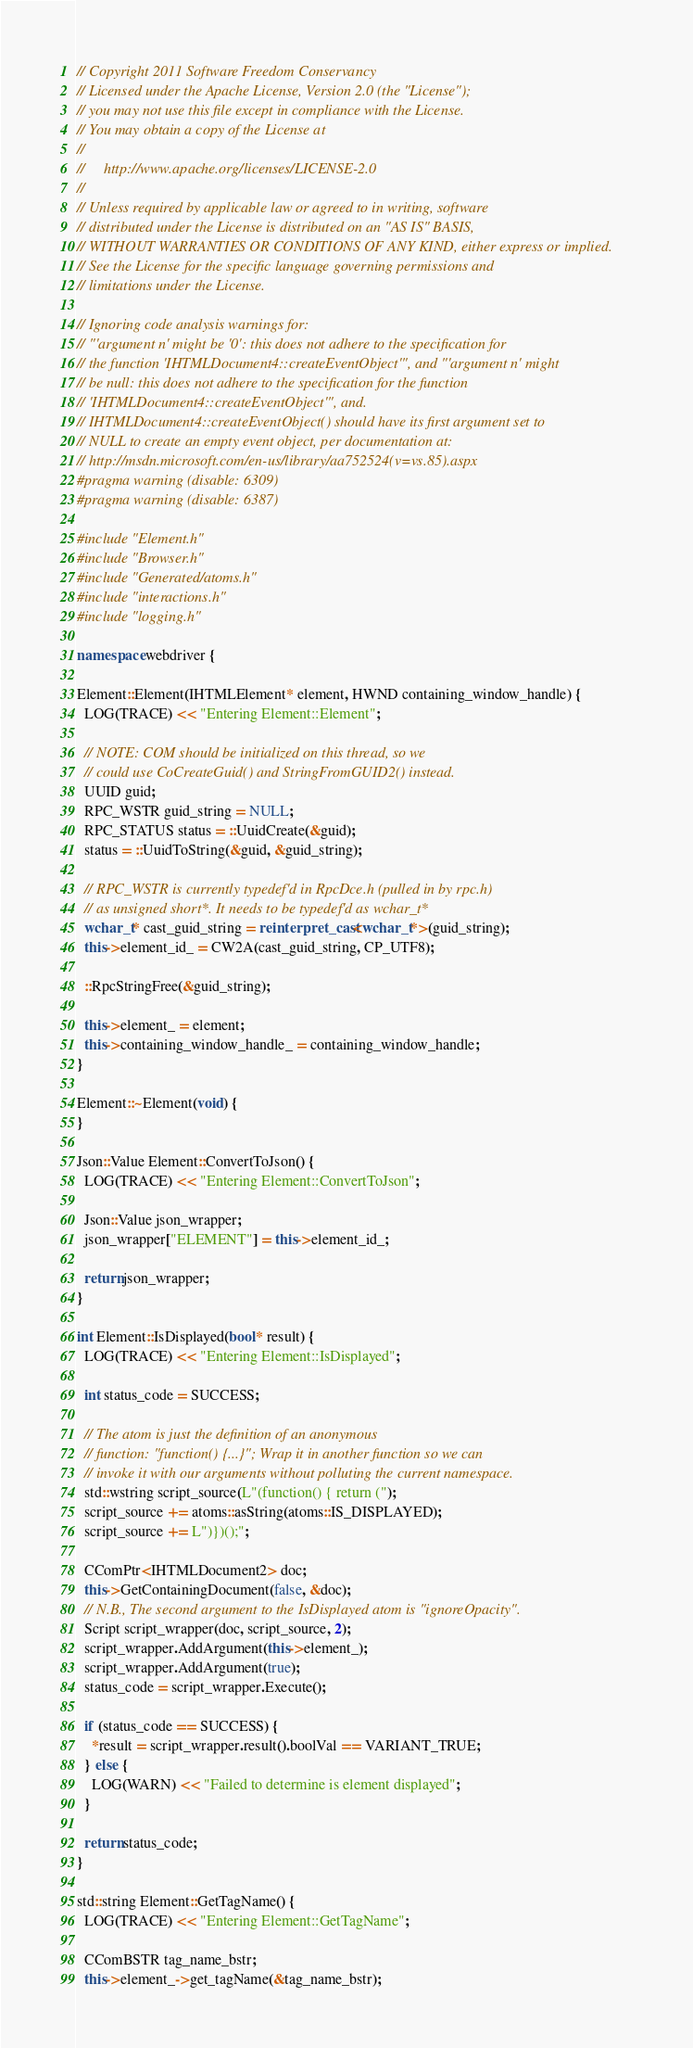Convert code to text. <code><loc_0><loc_0><loc_500><loc_500><_C++_>// Copyright 2011 Software Freedom Conservancy
// Licensed under the Apache License, Version 2.0 (the "License");
// you may not use this file except in compliance with the License.
// You may obtain a copy of the License at
//
//     http://www.apache.org/licenses/LICENSE-2.0
//
// Unless required by applicable law or agreed to in writing, software
// distributed under the License is distributed on an "AS IS" BASIS,
// WITHOUT WARRANTIES OR CONDITIONS OF ANY KIND, either express or implied.
// See the License for the specific language governing permissions and
// limitations under the License.

// Ignoring code analysis warnings for:
// "'argument n' might be '0': this does not adhere to the specification for 
// the function 'IHTMLDocument4::createEventObject'", and "'argument n' might
// be null: this does not adhere to the specification for the function
// 'IHTMLDocument4::createEventObject'", and. 
// IHTMLDocument4::createEventObject() should have its first argument set to 
// NULL to create an empty event object, per documentation at:
// http://msdn.microsoft.com/en-us/library/aa752524(v=vs.85).aspx
#pragma warning (disable: 6309)
#pragma warning (disable: 6387)

#include "Element.h"
#include "Browser.h"
#include "Generated/atoms.h"
#include "interactions.h"
#include "logging.h"

namespace webdriver {

Element::Element(IHTMLElement* element, HWND containing_window_handle) {
  LOG(TRACE) << "Entering Element::Element";

  // NOTE: COM should be initialized on this thread, so we
  // could use CoCreateGuid() and StringFromGUID2() instead.
  UUID guid;
  RPC_WSTR guid_string = NULL;
  RPC_STATUS status = ::UuidCreate(&guid);
  status = ::UuidToString(&guid, &guid_string);

  // RPC_WSTR is currently typedef'd in RpcDce.h (pulled in by rpc.h)
  // as unsigned short*. It needs to be typedef'd as wchar_t* 
  wchar_t* cast_guid_string = reinterpret_cast<wchar_t*>(guid_string);
  this->element_id_ = CW2A(cast_guid_string, CP_UTF8);

  ::RpcStringFree(&guid_string);

  this->element_ = element;
  this->containing_window_handle_ = containing_window_handle;
}

Element::~Element(void) {
}

Json::Value Element::ConvertToJson() {
  LOG(TRACE) << "Entering Element::ConvertToJson";

  Json::Value json_wrapper;
  json_wrapper["ELEMENT"] = this->element_id_;

  return json_wrapper;
}

int Element::IsDisplayed(bool* result) {
  LOG(TRACE) << "Entering Element::IsDisplayed";

  int status_code = SUCCESS;

  // The atom is just the definition of an anonymous
  // function: "function() {...}"; Wrap it in another function so we can
  // invoke it with our arguments without polluting the current namespace.
  std::wstring script_source(L"(function() { return (");
  script_source += atoms::asString(atoms::IS_DISPLAYED);
  script_source += L")})();";

  CComPtr<IHTMLDocument2> doc;
  this->GetContainingDocument(false, &doc);
  // N.B., The second argument to the IsDisplayed atom is "ignoreOpacity".
  Script script_wrapper(doc, script_source, 2);
  script_wrapper.AddArgument(this->element_);
  script_wrapper.AddArgument(true);
  status_code = script_wrapper.Execute();

  if (status_code == SUCCESS) {
    *result = script_wrapper.result().boolVal == VARIANT_TRUE;
  } else {
    LOG(WARN) << "Failed to determine is element displayed";
  }

  return status_code;
}

std::string Element::GetTagName() {
  LOG(TRACE) << "Entering Element::GetTagName";

  CComBSTR tag_name_bstr;
  this->element_->get_tagName(&tag_name_bstr);</code> 